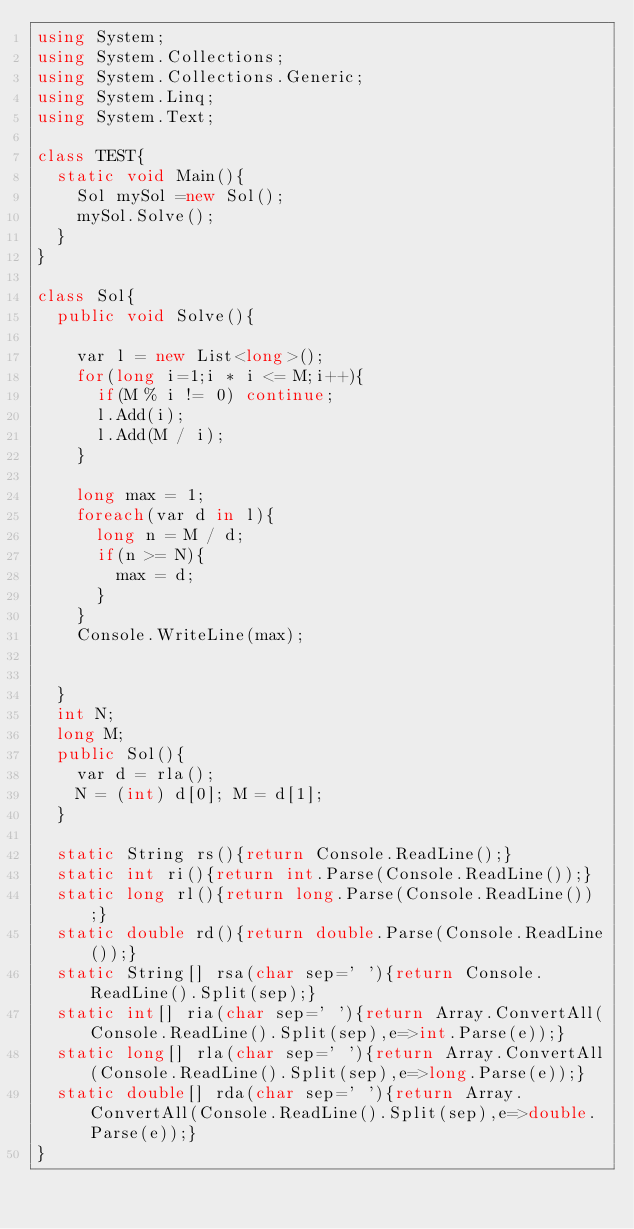Convert code to text. <code><loc_0><loc_0><loc_500><loc_500><_C#_>using System;
using System.Collections;
using System.Collections.Generic;
using System.Linq;
using System.Text;

class TEST{
	static void Main(){
		Sol mySol =new Sol();
		mySol.Solve();
	}
}

class Sol{
	public void Solve(){
		
		var l = new List<long>();
		for(long i=1;i * i <= M;i++){
			if(M % i != 0) continue;
			l.Add(i);
			l.Add(M / i);
		}
		
		long max = 1;
		foreach(var d in l){
			long n = M / d;
			if(n >= N){
				max = d;
			}
		}
		Console.WriteLine(max);
		
		
	}
	int N;
	long M;
	public Sol(){
		var d = rla();
		N = (int) d[0]; M = d[1];
	}

	static String rs(){return Console.ReadLine();}
	static int ri(){return int.Parse(Console.ReadLine());}
	static long rl(){return long.Parse(Console.ReadLine());}
	static double rd(){return double.Parse(Console.ReadLine());}
	static String[] rsa(char sep=' '){return Console.ReadLine().Split(sep);}
	static int[] ria(char sep=' '){return Array.ConvertAll(Console.ReadLine().Split(sep),e=>int.Parse(e));}
	static long[] rla(char sep=' '){return Array.ConvertAll(Console.ReadLine().Split(sep),e=>long.Parse(e));}
	static double[] rda(char sep=' '){return Array.ConvertAll(Console.ReadLine().Split(sep),e=>double.Parse(e));}
}
</code> 